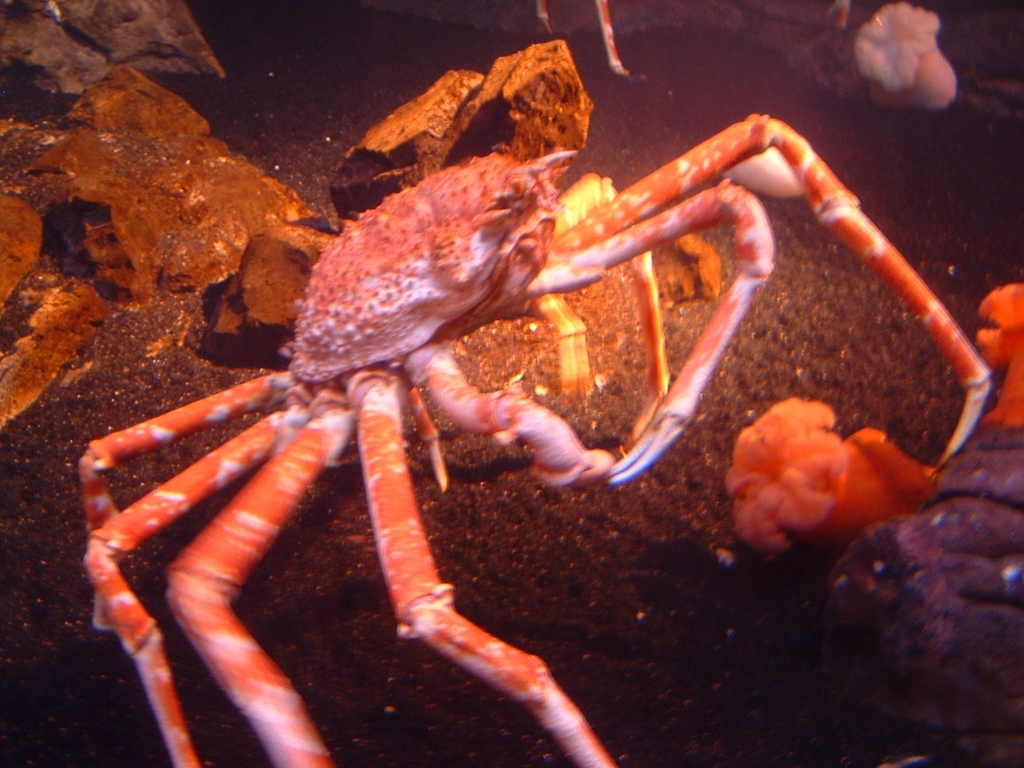This crab seems quite large. How big do spider crabs typically get? Spider crabs vary in size with several species around the world. Some, like the Japanese spider crab, can have a leg span of up to 3.8 meters (12.5 feet), making them one of the largest arthropods. The crab in this image appears to be a sizable specimen, although without more context it's difficult to accurately determine its scale. Generally, spider crabs are known for their long legs relative to their body size. 